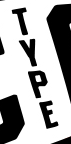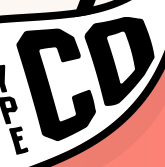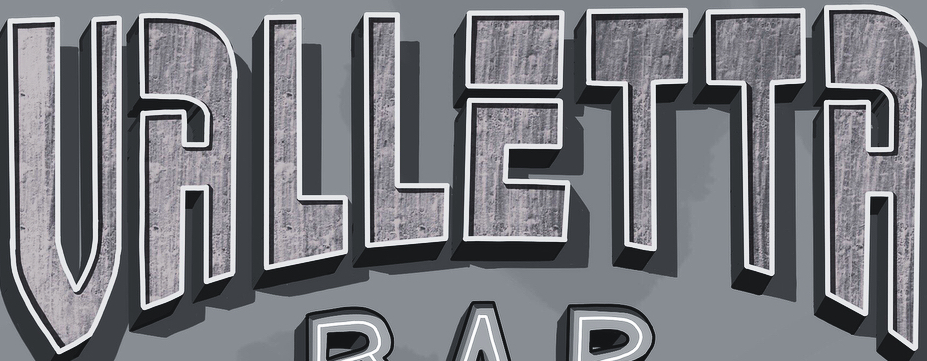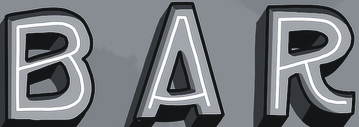Identify the words shown in these images in order, separated by a semicolon. TYPE; CD; VALLETTA; BAR 